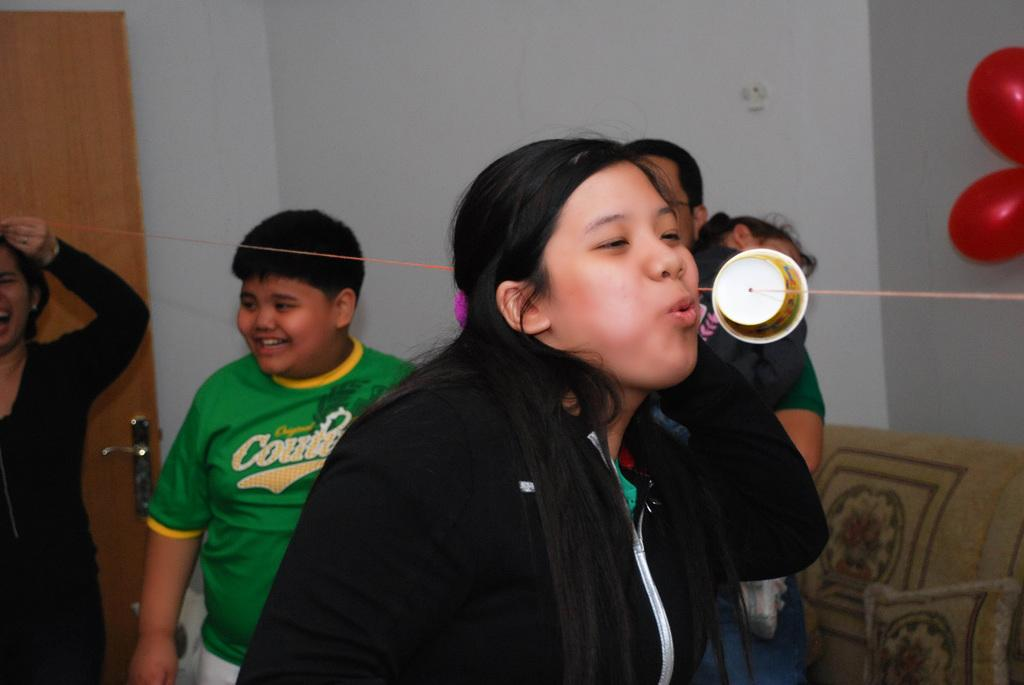Who or what can be seen in the image? There are people in the image. What object with a wire is present in the image? There is a cup with a wire in the image. What type of soft furnishings are visible in the image? There are pillows in the image. What architectural features can be seen in the background of the image? There is a wall and a door in the background of the image. What decorative items are present in the background of the image? There are red balloons in the background of the image. What type of dress is the father wearing in the image? There is no father or dress present in the image. How does the person in the image clear their throat? There is no indication of anyone clearing their throat in the image. 